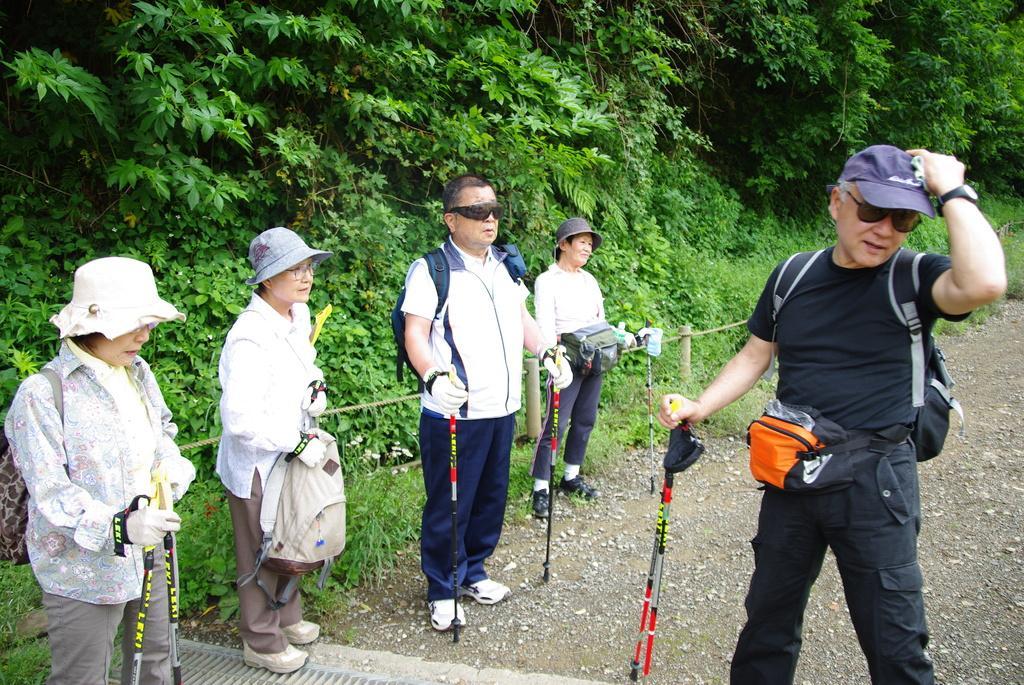Describe this image in one or two sentences. In this image I can see five persons are standing on the ground and holding sticks in their hand. In the background I can see grass and trees. This image is taken during a day. 